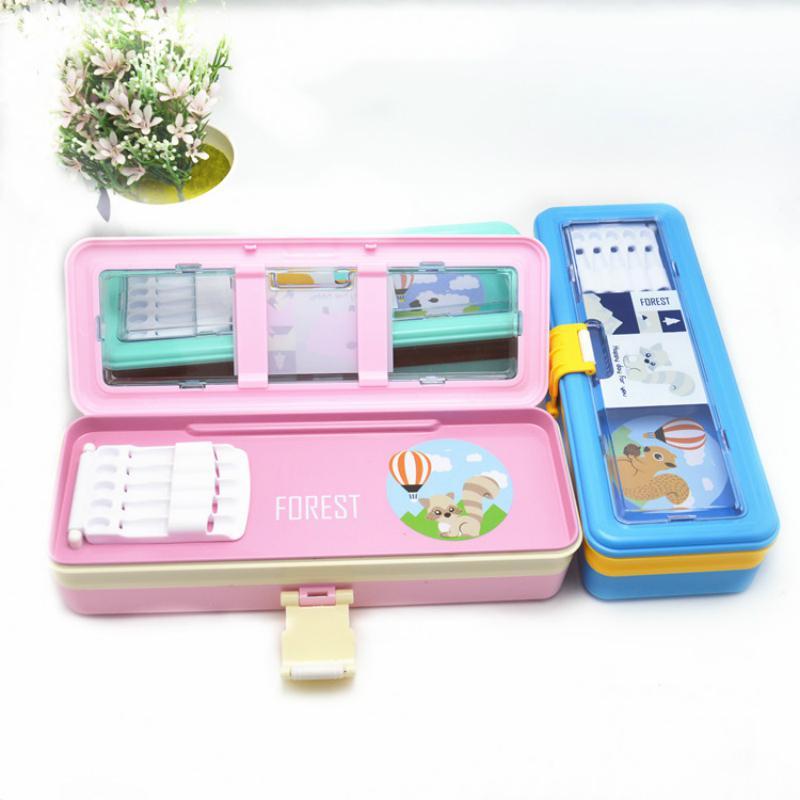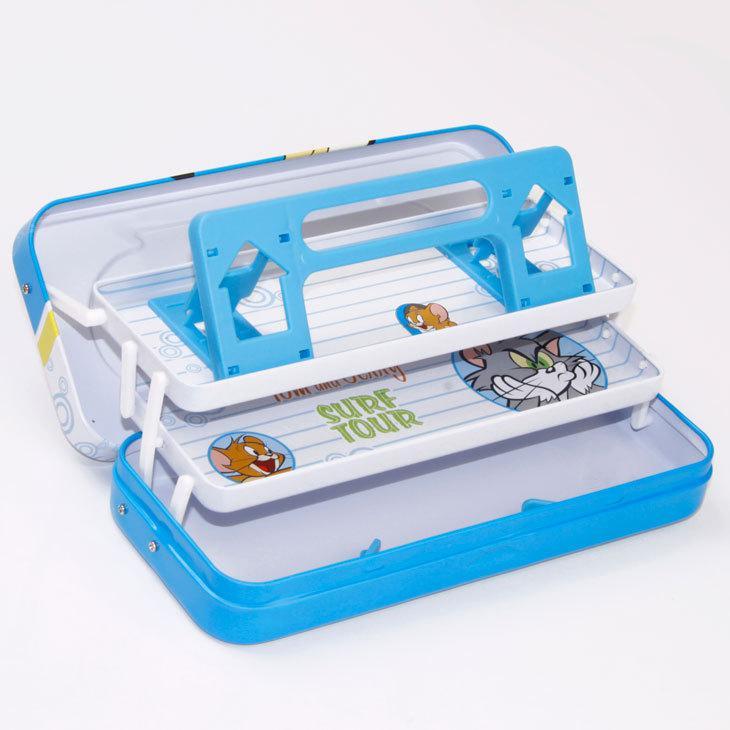The first image is the image on the left, the second image is the image on the right. For the images shown, is this caption "One image shows a filled box-shaped pink pencil case with a flip-up lid, and the other image shows several versions of closed cases with cartoon creatures on the fronts." true? Answer yes or no. No. The first image is the image on the left, the second image is the image on the right. Evaluate the accuracy of this statement regarding the images: "One of the images has a container of flowers in the background.". Is it true? Answer yes or no. Yes. 